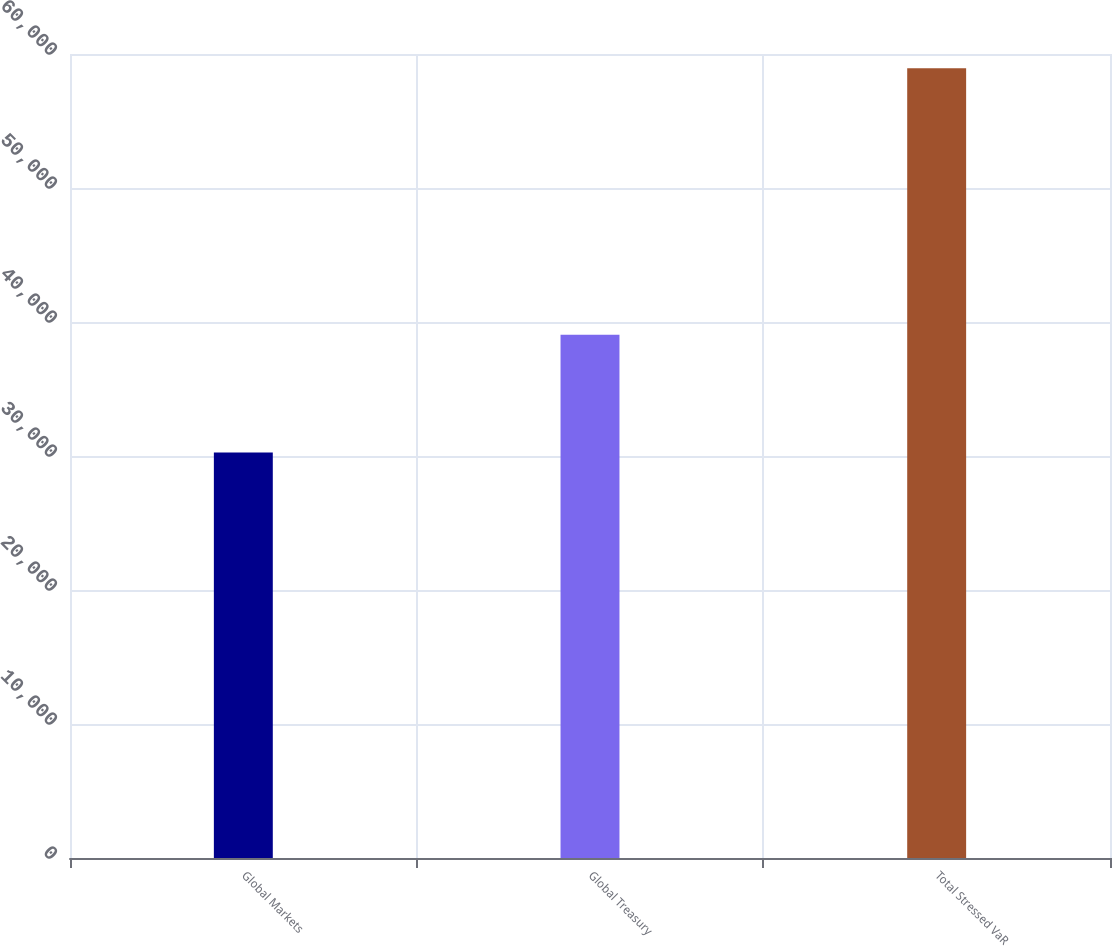Convert chart. <chart><loc_0><loc_0><loc_500><loc_500><bar_chart><fcel>Global Markets<fcel>Global Treasury<fcel>Total Stressed VaR<nl><fcel>30255<fcel>39050<fcel>58945<nl></chart> 